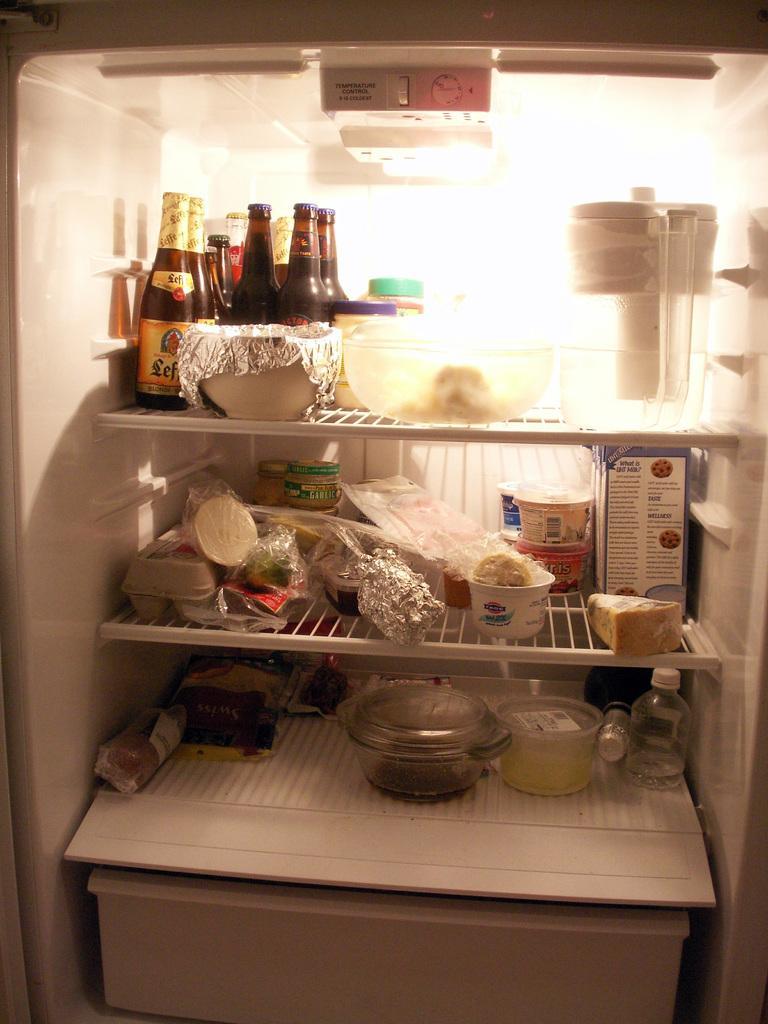Please provide a concise description of this image. In this picture there is interior of a refrigerator which has three shelves in it and there are few eatables and drinks placed in each shelf. 